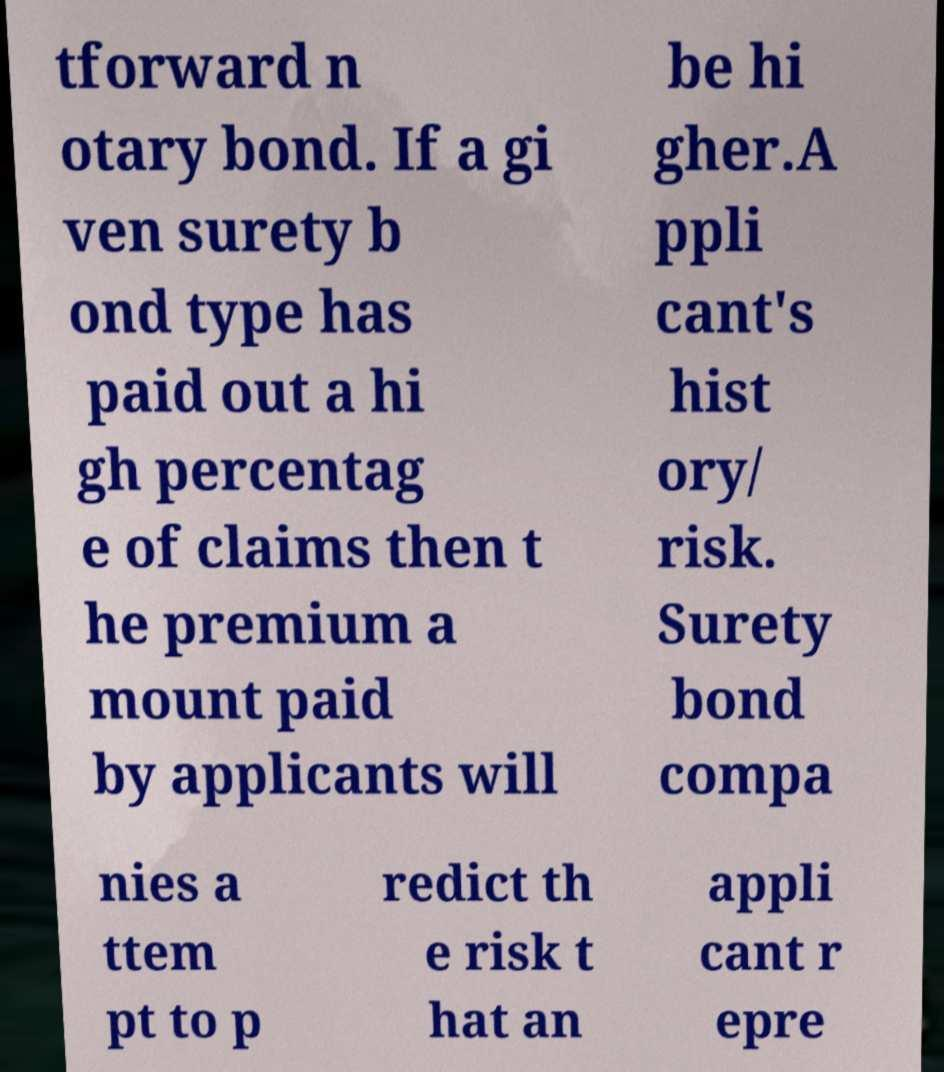Could you assist in decoding the text presented in this image and type it out clearly? tforward n otary bond. If a gi ven surety b ond type has paid out a hi gh percentag e of claims then t he premium a mount paid by applicants will be hi gher.A ppli cant's hist ory/ risk. Surety bond compa nies a ttem pt to p redict th e risk t hat an appli cant r epre 